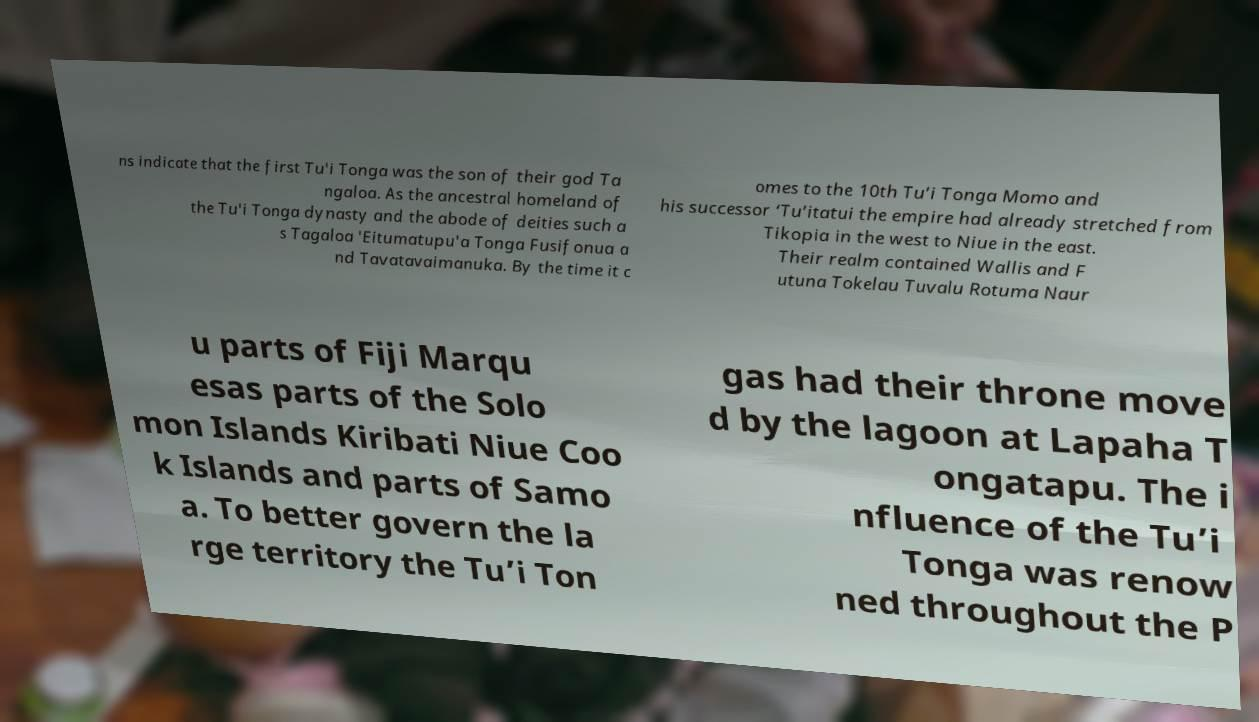I need the written content from this picture converted into text. Can you do that? ns indicate that the first Tu'i Tonga was the son of their god Ta ngaloa. As the ancestral homeland of the Tu'i Tonga dynasty and the abode of deities such a s Tagaloa 'Eitumatupu'a Tonga Fusifonua a nd Tavatavaimanuka. By the time it c omes to the 10th Tu’i Tonga Momo and his successor ‘Tu’itatui the empire had already stretched from Tikopia in the west to Niue in the east. Their realm contained Wallis and F utuna Tokelau Tuvalu Rotuma Naur u parts of Fiji Marqu esas parts of the Solo mon Islands Kiribati Niue Coo k Islands and parts of Samo a. To better govern the la rge territory the Tu’i Ton gas had their throne move d by the lagoon at Lapaha T ongatapu. The i nfluence of the Tu’i Tonga was renow ned throughout the P 